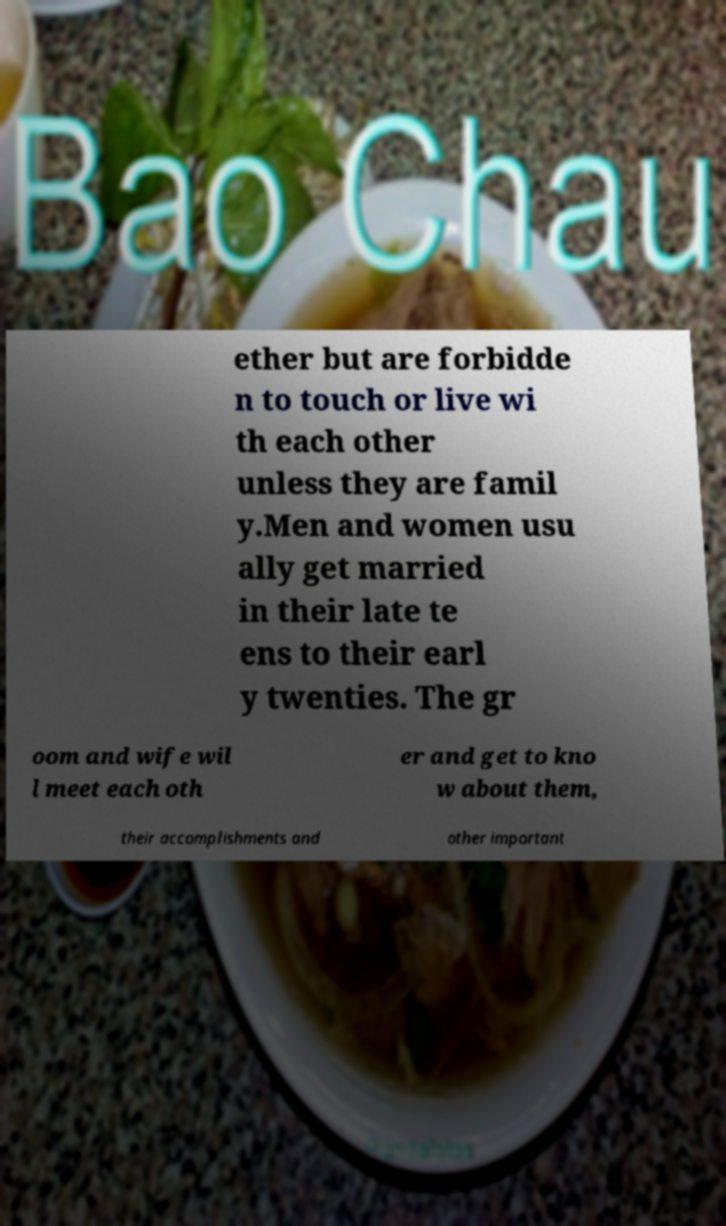For documentation purposes, I need the text within this image transcribed. Could you provide that? ether but are forbidde n to touch or live wi th each other unless they are famil y.Men and women usu ally get married in their late te ens to their earl y twenties. The gr oom and wife wil l meet each oth er and get to kno w about them, their accomplishments and other important 